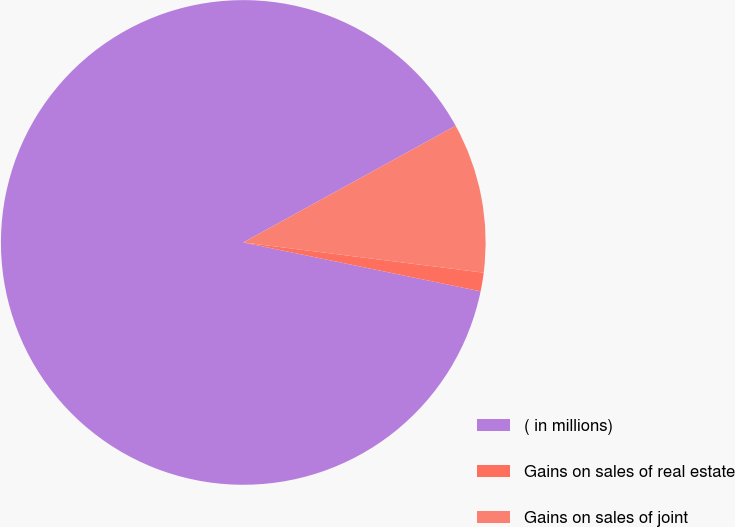<chart> <loc_0><loc_0><loc_500><loc_500><pie_chart><fcel>( in millions)<fcel>Gains on sales of real estate<fcel>Gains on sales of joint<nl><fcel>88.76%<fcel>1.24%<fcel>9.99%<nl></chart> 